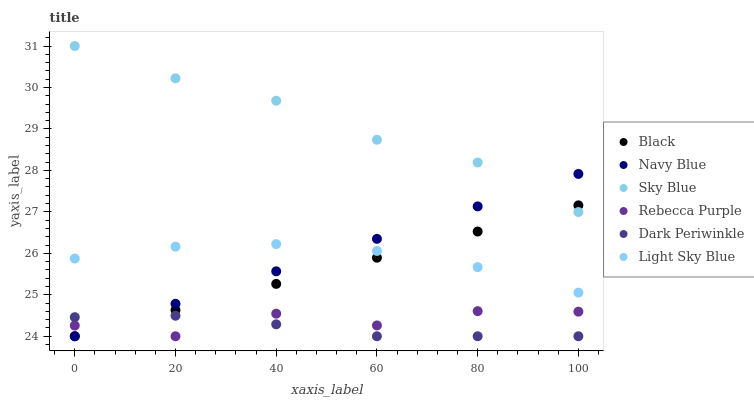Does Dark Periwinkle have the minimum area under the curve?
Answer yes or no. Yes. Does Sky Blue have the maximum area under the curve?
Answer yes or no. Yes. Does Light Sky Blue have the minimum area under the curve?
Answer yes or no. No. Does Light Sky Blue have the maximum area under the curve?
Answer yes or no. No. Is Black the smoothest?
Answer yes or no. Yes. Is Rebecca Purple the roughest?
Answer yes or no. Yes. Is Light Sky Blue the smoothest?
Answer yes or no. No. Is Light Sky Blue the roughest?
Answer yes or no. No. Does Navy Blue have the lowest value?
Answer yes or no. Yes. Does Light Sky Blue have the lowest value?
Answer yes or no. No. Does Sky Blue have the highest value?
Answer yes or no. Yes. Does Light Sky Blue have the highest value?
Answer yes or no. No. Is Rebecca Purple less than Sky Blue?
Answer yes or no. Yes. Is Light Sky Blue greater than Rebecca Purple?
Answer yes or no. Yes. Does Navy Blue intersect Dark Periwinkle?
Answer yes or no. Yes. Is Navy Blue less than Dark Periwinkle?
Answer yes or no. No. Is Navy Blue greater than Dark Periwinkle?
Answer yes or no. No. Does Rebecca Purple intersect Sky Blue?
Answer yes or no. No. 